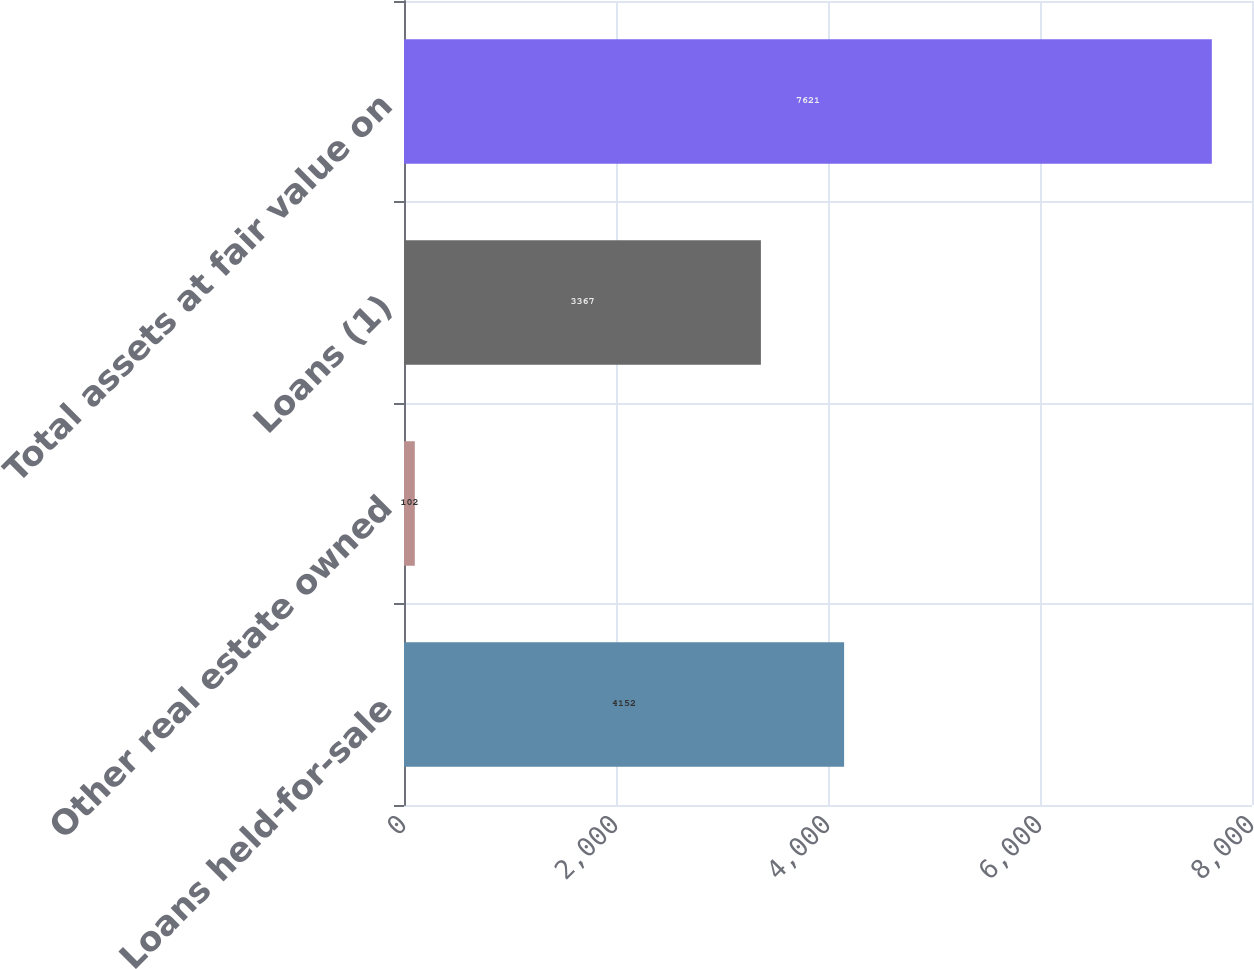Convert chart to OTSL. <chart><loc_0><loc_0><loc_500><loc_500><bar_chart><fcel>Loans held-for-sale<fcel>Other real estate owned<fcel>Loans (1)<fcel>Total assets at fair value on<nl><fcel>4152<fcel>102<fcel>3367<fcel>7621<nl></chart> 